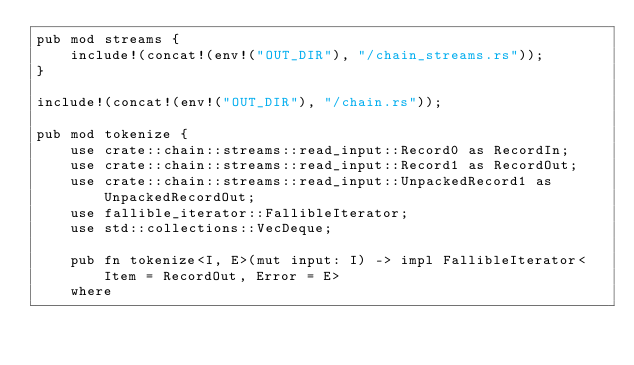Convert code to text. <code><loc_0><loc_0><loc_500><loc_500><_Rust_>pub mod streams {
    include!(concat!(env!("OUT_DIR"), "/chain_streams.rs"));
}

include!(concat!(env!("OUT_DIR"), "/chain.rs"));

pub mod tokenize {
    use crate::chain::streams::read_input::Record0 as RecordIn;
    use crate::chain::streams::read_input::Record1 as RecordOut;
    use crate::chain::streams::read_input::UnpackedRecord1 as UnpackedRecordOut;
    use fallible_iterator::FallibleIterator;
    use std::collections::VecDeque;

    pub fn tokenize<I, E>(mut input: I) -> impl FallibleIterator<Item = RecordOut, Error = E>
    where</code> 